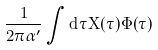Convert formula to latex. <formula><loc_0><loc_0><loc_500><loc_500>\frac { 1 } { 2 \pi \alpha ^ { \prime } } \int d \tau X ( \tau ) \dot { \Phi } ( \tau )</formula> 